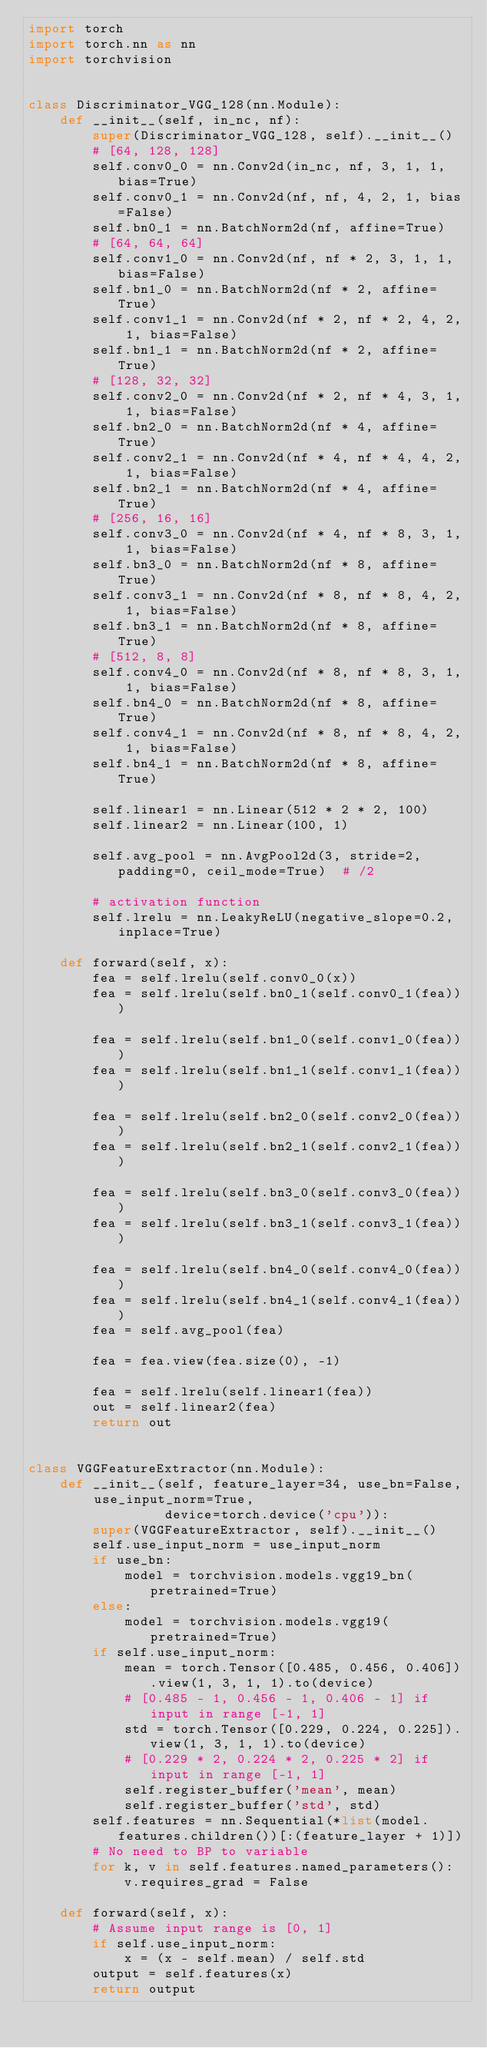<code> <loc_0><loc_0><loc_500><loc_500><_Python_>import torch
import torch.nn as nn
import torchvision


class Discriminator_VGG_128(nn.Module):
    def __init__(self, in_nc, nf):
        super(Discriminator_VGG_128, self).__init__()
        # [64, 128, 128]
        self.conv0_0 = nn.Conv2d(in_nc, nf, 3, 1, 1, bias=True)
        self.conv0_1 = nn.Conv2d(nf, nf, 4, 2, 1, bias=False)
        self.bn0_1 = nn.BatchNorm2d(nf, affine=True)
        # [64, 64, 64]
        self.conv1_0 = nn.Conv2d(nf, nf * 2, 3, 1, 1, bias=False)
        self.bn1_0 = nn.BatchNorm2d(nf * 2, affine=True)
        self.conv1_1 = nn.Conv2d(nf * 2, nf * 2, 4, 2, 1, bias=False)
        self.bn1_1 = nn.BatchNorm2d(nf * 2, affine=True)
        # [128, 32, 32]
        self.conv2_0 = nn.Conv2d(nf * 2, nf * 4, 3, 1, 1, bias=False)
        self.bn2_0 = nn.BatchNorm2d(nf * 4, affine=True)
        self.conv2_1 = nn.Conv2d(nf * 4, nf * 4, 4, 2, 1, bias=False)
        self.bn2_1 = nn.BatchNorm2d(nf * 4, affine=True)
        # [256, 16, 16]
        self.conv3_0 = nn.Conv2d(nf * 4, nf * 8, 3, 1, 1, bias=False)
        self.bn3_0 = nn.BatchNorm2d(nf * 8, affine=True)
        self.conv3_1 = nn.Conv2d(nf * 8, nf * 8, 4, 2, 1, bias=False)
        self.bn3_1 = nn.BatchNorm2d(nf * 8, affine=True)
        # [512, 8, 8]
        self.conv4_0 = nn.Conv2d(nf * 8, nf * 8, 3, 1, 1, bias=False)
        self.bn4_0 = nn.BatchNorm2d(nf * 8, affine=True)
        self.conv4_1 = nn.Conv2d(nf * 8, nf * 8, 4, 2, 1, bias=False)
        self.bn4_1 = nn.BatchNorm2d(nf * 8, affine=True)

        self.linear1 = nn.Linear(512 * 2 * 2, 100)
        self.linear2 = nn.Linear(100, 1)

        self.avg_pool = nn.AvgPool2d(3, stride=2, padding=0, ceil_mode=True)  # /2

        # activation function
        self.lrelu = nn.LeakyReLU(negative_slope=0.2, inplace=True)

    def forward(self, x):
        fea = self.lrelu(self.conv0_0(x))
        fea = self.lrelu(self.bn0_1(self.conv0_1(fea)))

        fea = self.lrelu(self.bn1_0(self.conv1_0(fea)))
        fea = self.lrelu(self.bn1_1(self.conv1_1(fea)))

        fea = self.lrelu(self.bn2_0(self.conv2_0(fea)))
        fea = self.lrelu(self.bn2_1(self.conv2_1(fea)))

        fea = self.lrelu(self.bn3_0(self.conv3_0(fea)))
        fea = self.lrelu(self.bn3_1(self.conv3_1(fea)))

        fea = self.lrelu(self.bn4_0(self.conv4_0(fea)))
        fea = self.lrelu(self.bn4_1(self.conv4_1(fea)))
        fea = self.avg_pool(fea)

        fea = fea.view(fea.size(0), -1)

        fea = self.lrelu(self.linear1(fea))
        out = self.linear2(fea)
        return out


class VGGFeatureExtractor(nn.Module):
    def __init__(self, feature_layer=34, use_bn=False, use_input_norm=True,
                 device=torch.device('cpu')):
        super(VGGFeatureExtractor, self).__init__()
        self.use_input_norm = use_input_norm
        if use_bn:
            model = torchvision.models.vgg19_bn(pretrained=True)
        else:
            model = torchvision.models.vgg19(pretrained=True)
        if self.use_input_norm:
            mean = torch.Tensor([0.485, 0.456, 0.406]).view(1, 3, 1, 1).to(device)
            # [0.485 - 1, 0.456 - 1, 0.406 - 1] if input in range [-1, 1]
            std = torch.Tensor([0.229, 0.224, 0.225]).view(1, 3, 1, 1).to(device)
            # [0.229 * 2, 0.224 * 2, 0.225 * 2] if input in range [-1, 1]
            self.register_buffer('mean', mean)
            self.register_buffer('std', std)
        self.features = nn.Sequential(*list(model.features.children())[:(feature_layer + 1)])
        # No need to BP to variable
        for k, v in self.features.named_parameters():
            v.requires_grad = False

    def forward(self, x):
        # Assume input range is [0, 1]
        if self.use_input_norm:
            x = (x - self.mean) / self.std
        output = self.features(x)
        return output
</code> 